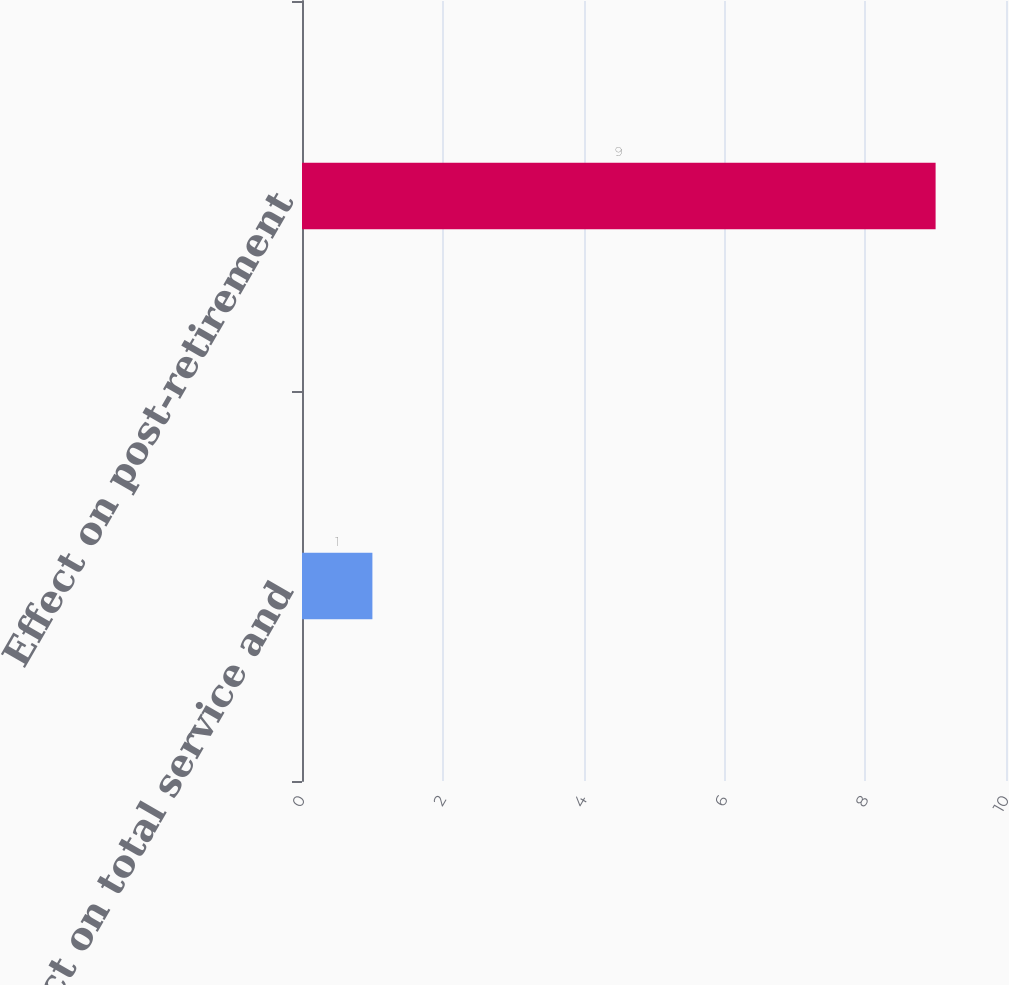Convert chart to OTSL. <chart><loc_0><loc_0><loc_500><loc_500><bar_chart><fcel>Effect on total service and<fcel>Effect on post-retirement<nl><fcel>1<fcel>9<nl></chart> 